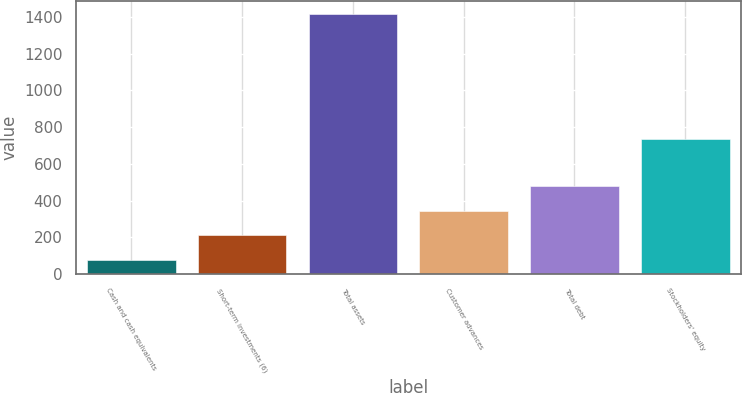<chart> <loc_0><loc_0><loc_500><loc_500><bar_chart><fcel>Cash and cash equivalents<fcel>Short-term investments (6)<fcel>Total assets<fcel>Customer advances<fcel>Total debt<fcel>Stockholders' equity<nl><fcel>77.2<fcel>211.04<fcel>1415.6<fcel>344.88<fcel>478.72<fcel>733.5<nl></chart> 